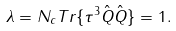Convert formula to latex. <formula><loc_0><loc_0><loc_500><loc_500>\lambda = N _ { c } T r \{ \tau ^ { 3 } \hat { Q } \hat { Q } \} = 1 .</formula> 